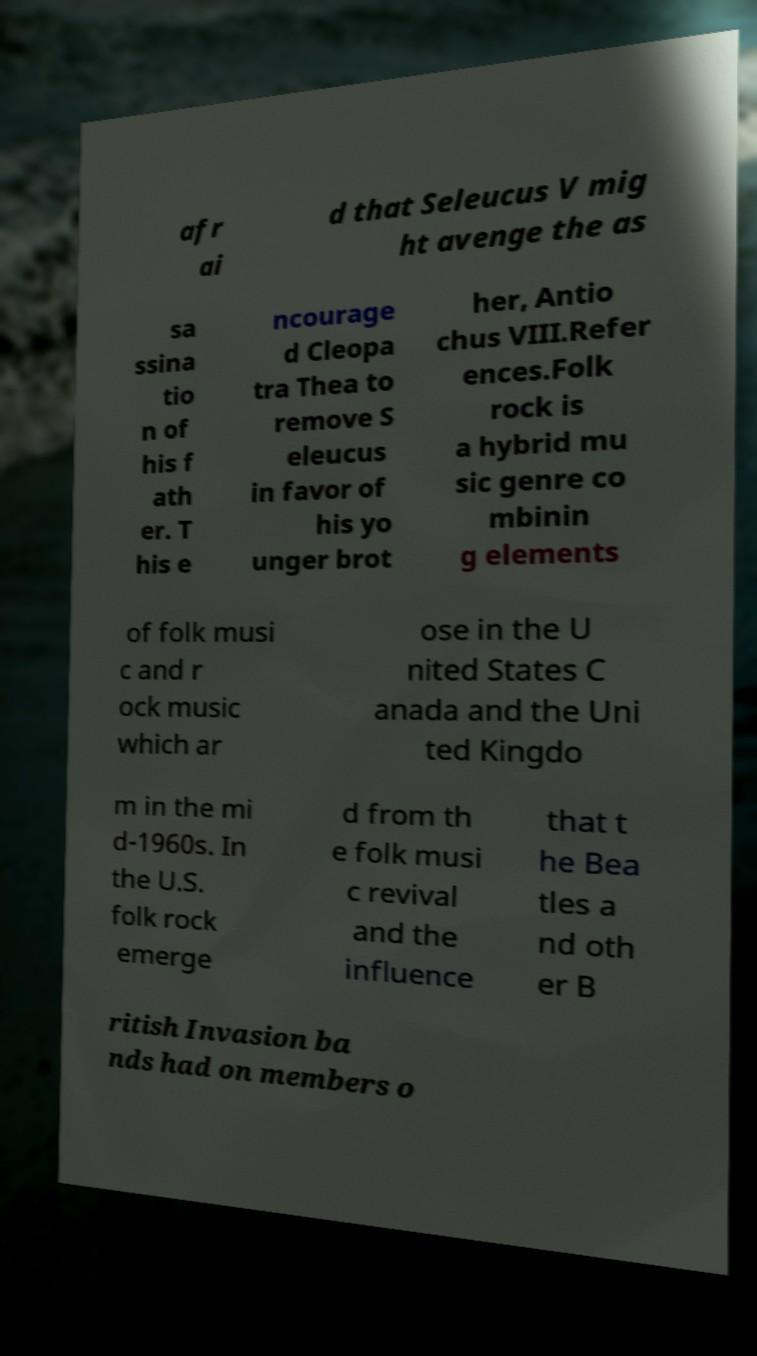There's text embedded in this image that I need extracted. Can you transcribe it verbatim? afr ai d that Seleucus V mig ht avenge the as sa ssina tio n of his f ath er. T his e ncourage d Cleopa tra Thea to remove S eleucus in favor of his yo unger brot her, Antio chus VIII.Refer ences.Folk rock is a hybrid mu sic genre co mbinin g elements of folk musi c and r ock music which ar ose in the U nited States C anada and the Uni ted Kingdo m in the mi d-1960s. In the U.S. folk rock emerge d from th e folk musi c revival and the influence that t he Bea tles a nd oth er B ritish Invasion ba nds had on members o 